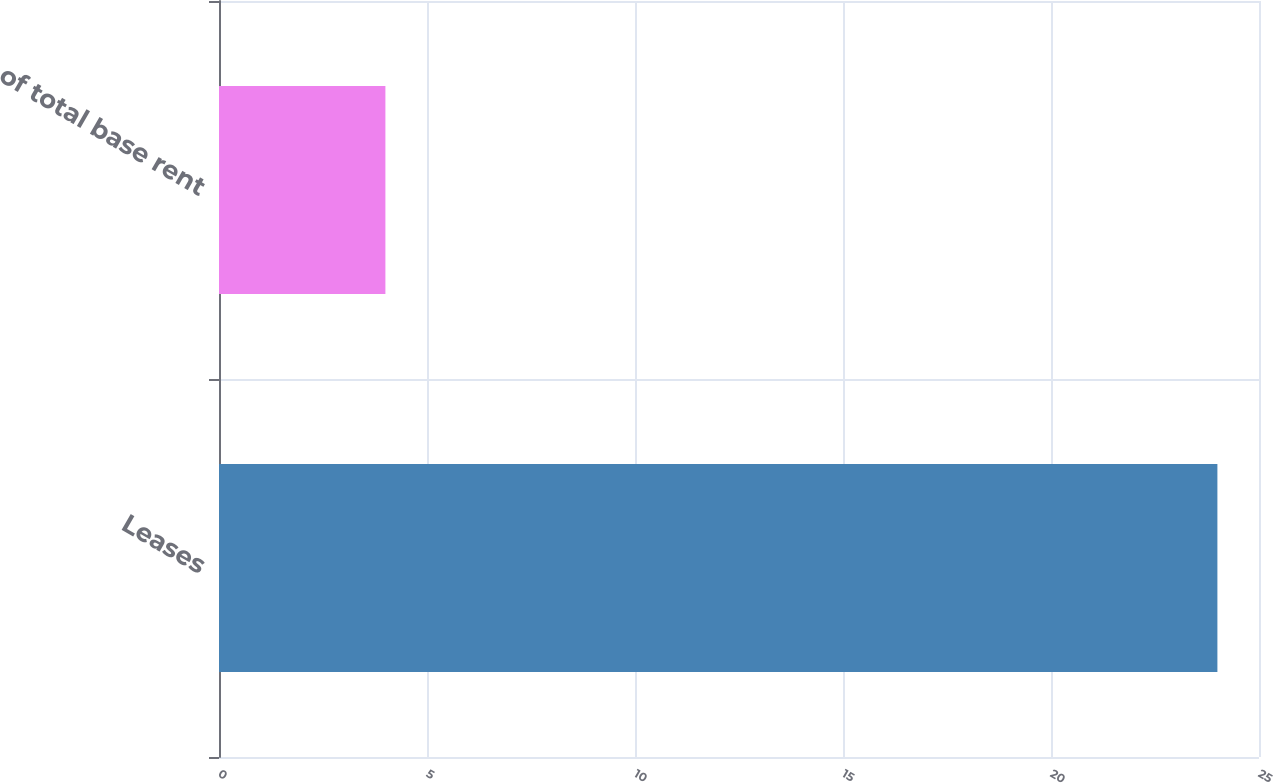<chart> <loc_0><loc_0><loc_500><loc_500><bar_chart><fcel>Leases<fcel>of total base rent<nl><fcel>24<fcel>4<nl></chart> 